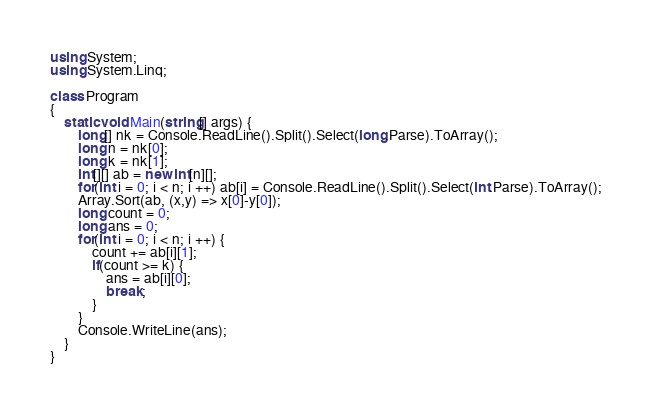Convert code to text. <code><loc_0><loc_0><loc_500><loc_500><_C#_>using System;
using System.Linq;

class Program
{
    static void Main(string[] args) {
        long[] nk = Console.ReadLine().Split().Select(long.Parse).ToArray();
        long n = nk[0];
        long k = nk[1];
        int[][] ab = new int[n][];
        for(int i = 0; i < n; i ++) ab[i] = Console.ReadLine().Split().Select(int.Parse).ToArray();
        Array.Sort(ab, (x,y) => x[0]-y[0]);
        long count = 0;
        long ans = 0;
        for(int i = 0; i < n; i ++) {
            count += ab[i][1];
            if(count >= k) {
                ans = ab[i][0];
                break;
            }
        }
        Console.WriteLine(ans);
    }
}
</code> 